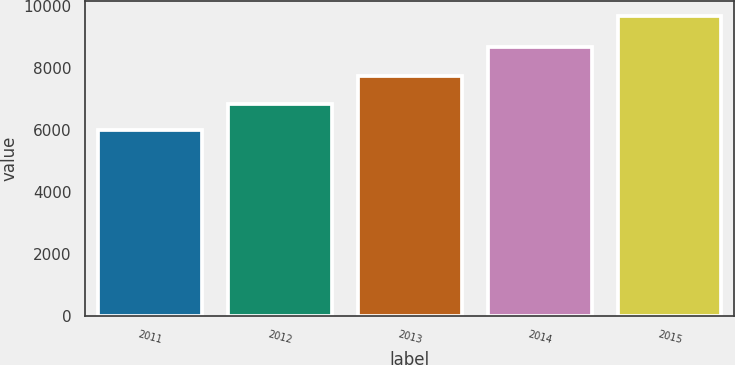Convert chart. <chart><loc_0><loc_0><loc_500><loc_500><bar_chart><fcel>2011<fcel>2012<fcel>2013<fcel>2014<fcel>2015<nl><fcel>5991<fcel>6829<fcel>7736<fcel>8694<fcel>9691<nl></chart> 